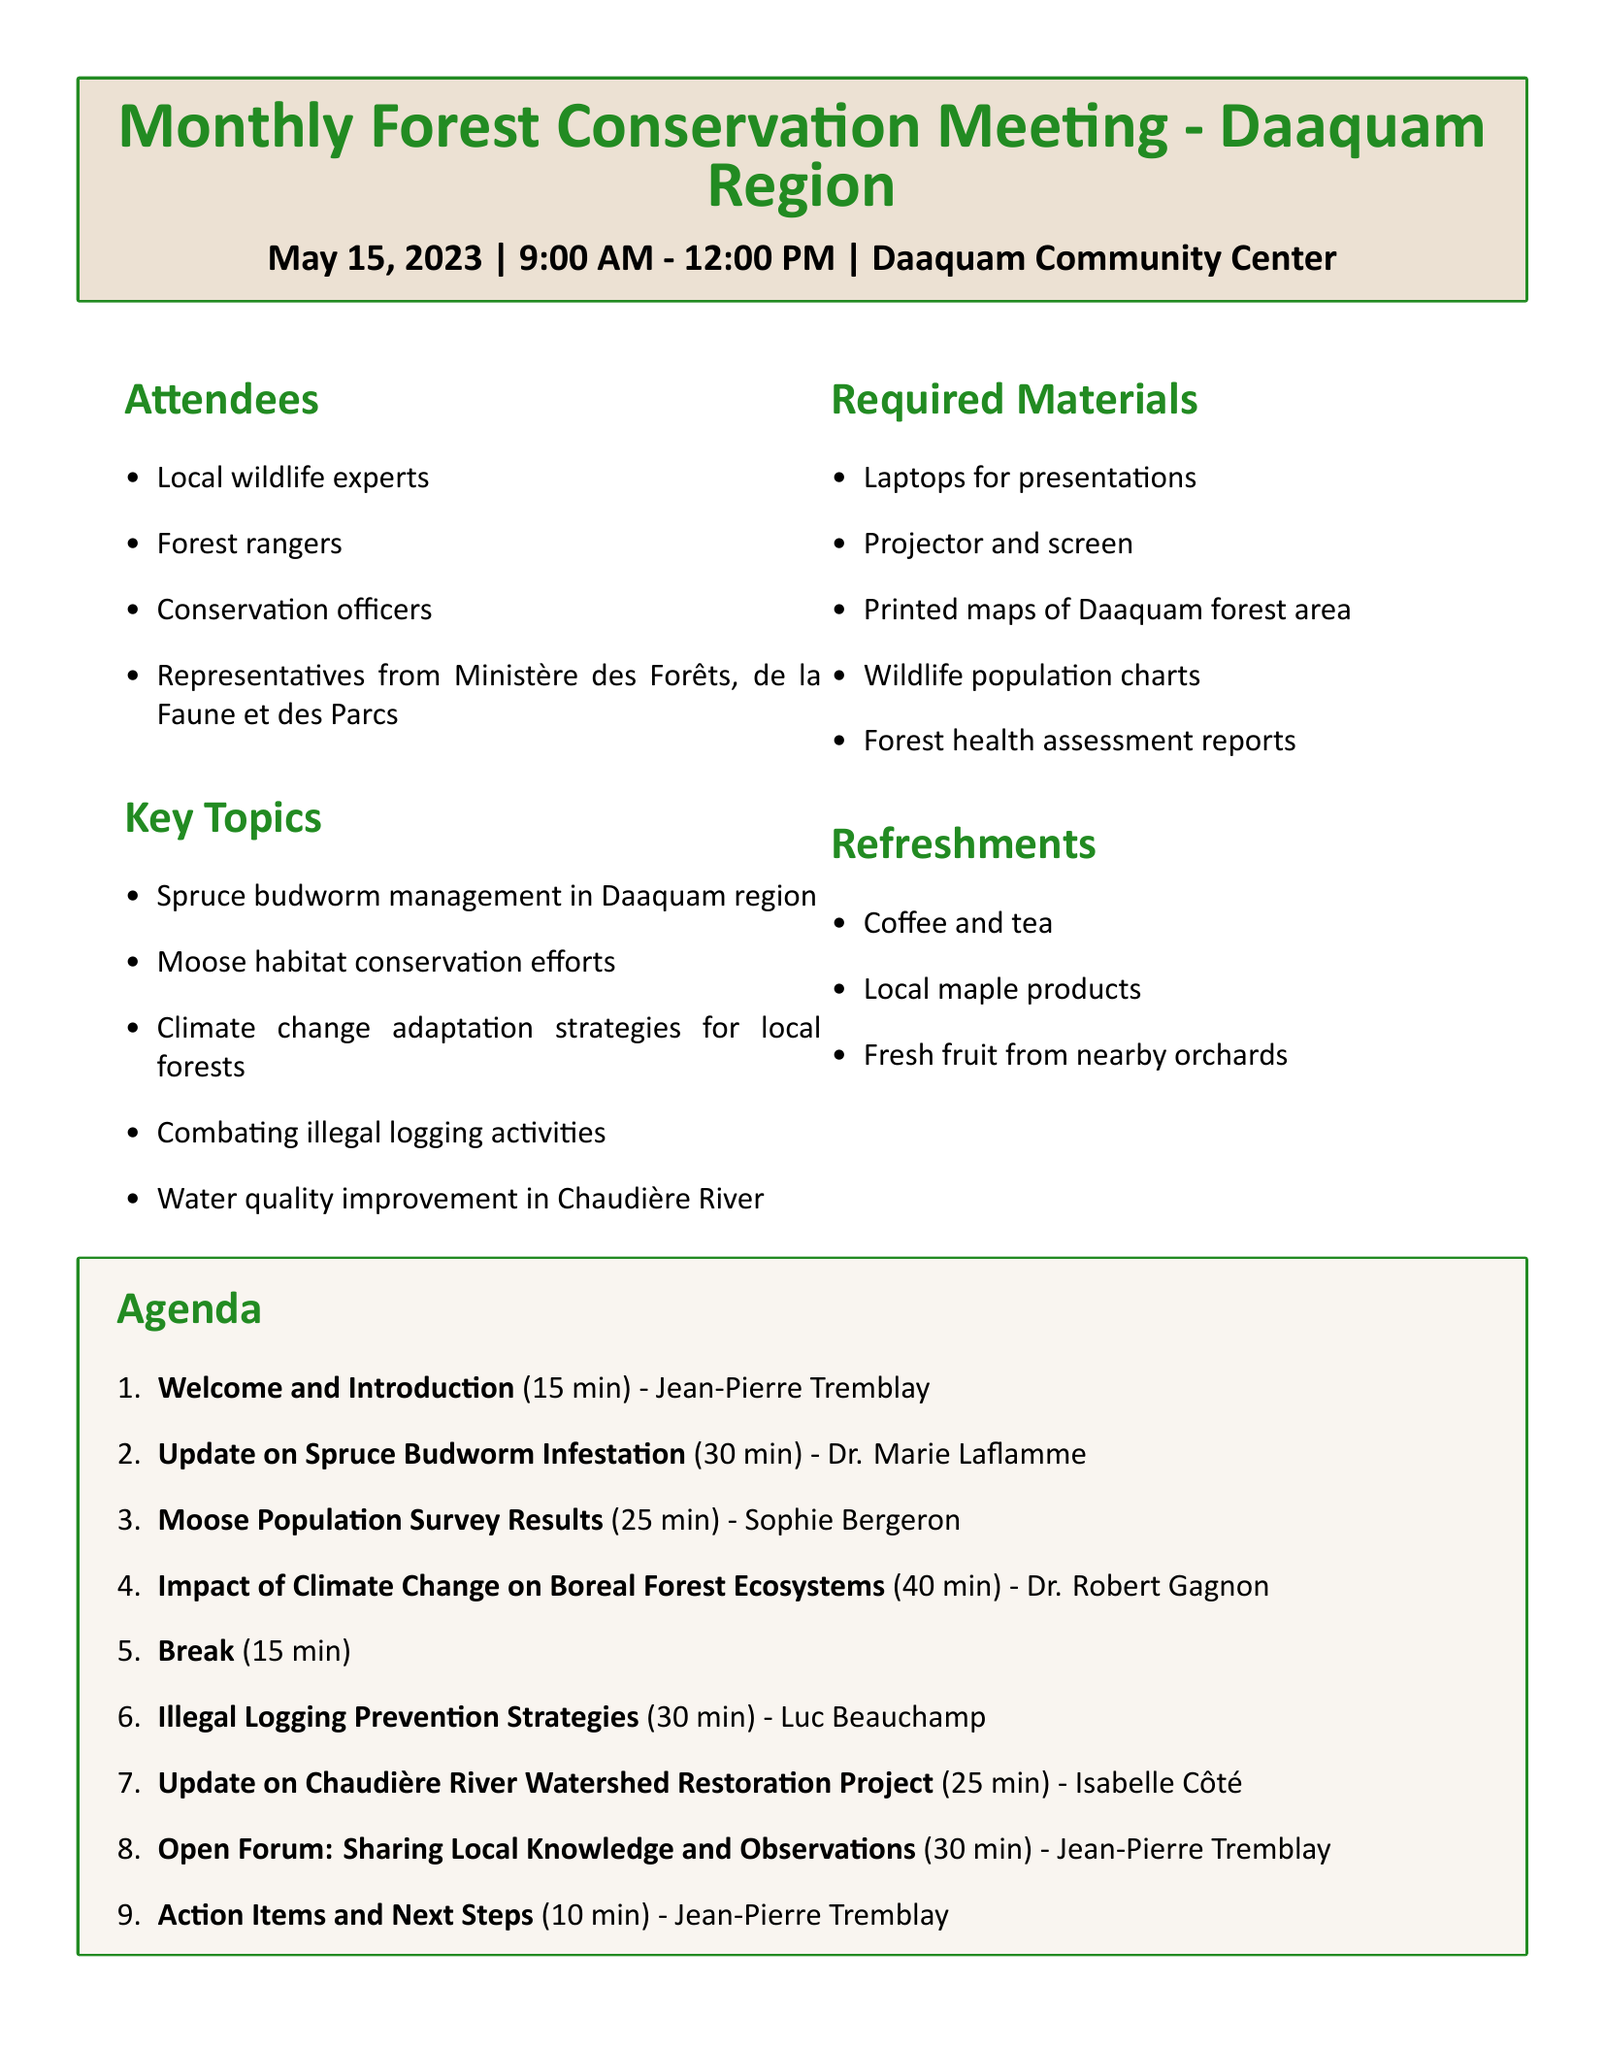What is the meeting date? The meeting date is specifically mentioned in the document as May 15, 2023.
Answer: May 15, 2023 Who is the presenter for the Moose Population Survey Results? The document lists Sophie Bergeron as the presenter for the Moose Population Survey Results.
Answer: Sophie Bergeron What is the duration of the update on Spruce Budworm Infestation? The duration for this agenda item is clearly stated in the document as 30 minutes.
Answer: 30 minutes How long is the break scheduled for? The break duration is provided as part of the agenda and is listed as 15 minutes.
Answer: 15 minutes Which organization does Luc Beauchamp represent? Luc Beauchamp is identified in the document as a Conservation Officer, thus indicating his affiliation.
Answer: Conservation Officer What is one of the key topics discussed related to water quality? The document mentions "Water quality improvement in Chaudière River" as one of the key topics.
Answer: Water quality improvement in Chaudière River Who is facilitating the Open Forum? The document specifies that Jean-Pierre Tremblay is the facilitator for the Open Forum.
Answer: Jean-Pierre Tremblay What kind of refreshments will be available at the meeting? The document lists coffee and tea, local maple products, and fresh fruit from nearby orchards as refreshments.
Answer: Coffee and tea, local maple products, fresh fruit from nearby orchards 